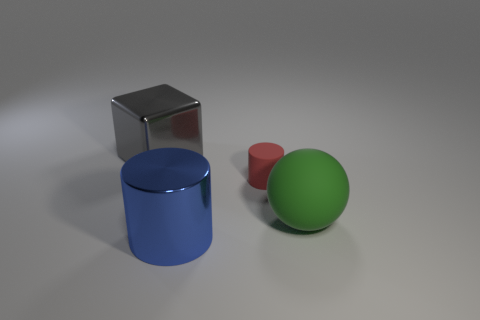Does the gray metal block have the same size as the object on the right side of the small matte thing?
Keep it short and to the point. Yes. How many blue cylinders are the same size as the blue shiny object?
Ensure brevity in your answer.  0. How many large things are either green matte cylinders or red objects?
Provide a short and direct response. 0. Is there a yellow matte cylinder?
Provide a short and direct response. No. Is the number of tiny red cylinders in front of the large ball greater than the number of red objects that are behind the red cylinder?
Offer a terse response. No. There is a metal object that is to the right of the metallic object behind the large rubber sphere; what is its color?
Provide a short and direct response. Blue. Is there another small thing of the same color as the tiny rubber thing?
Your answer should be very brief. No. There is a green rubber thing behind the cylinder in front of the cylinder behind the big cylinder; how big is it?
Make the answer very short. Large. There is a green thing; what shape is it?
Make the answer very short. Sphere. There is a large object behind the red cylinder; what number of matte cylinders are left of it?
Ensure brevity in your answer.  0. 